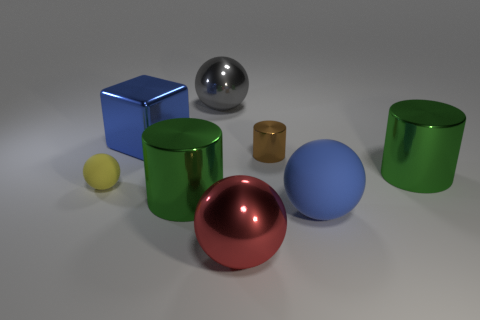Subtract all green cylinders. How many were subtracted if there are1green cylinders left? 1 Add 2 green rubber balls. How many objects exist? 10 Subtract all cylinders. How many objects are left? 5 Subtract 0 yellow blocks. How many objects are left? 8 Subtract all large blue metal objects. Subtract all tiny shiny cylinders. How many objects are left? 6 Add 3 big metallic objects. How many big metallic objects are left? 8 Add 6 large blue things. How many large blue things exist? 8 